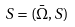Convert formula to latex. <formula><loc_0><loc_0><loc_500><loc_500>S = ( { \bar { \Omega } } , S )</formula> 